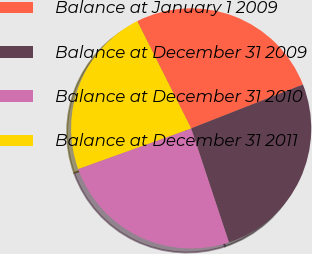Convert chart. <chart><loc_0><loc_0><loc_500><loc_500><pie_chart><fcel>Balance at January 1 2009<fcel>Balance at December 31 2009<fcel>Balance at December 31 2010<fcel>Balance at December 31 2011<nl><fcel>26.46%<fcel>25.85%<fcel>24.61%<fcel>23.07%<nl></chart> 